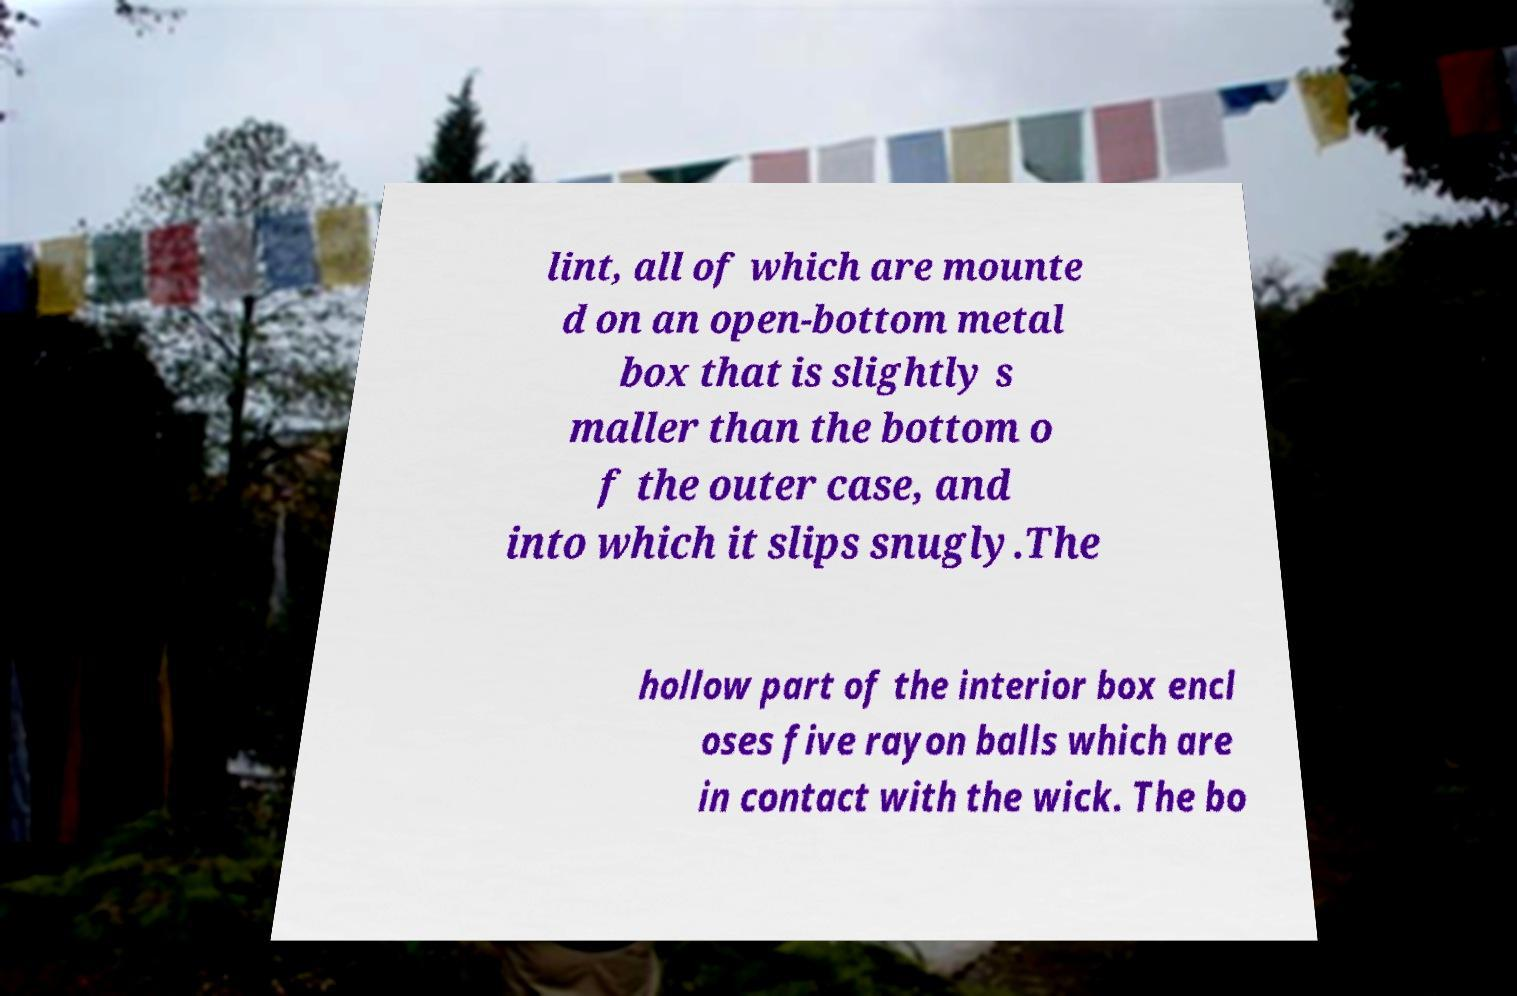Can you accurately transcribe the text from the provided image for me? lint, all of which are mounte d on an open-bottom metal box that is slightly s maller than the bottom o f the outer case, and into which it slips snugly.The hollow part of the interior box encl oses five rayon balls which are in contact with the wick. The bo 